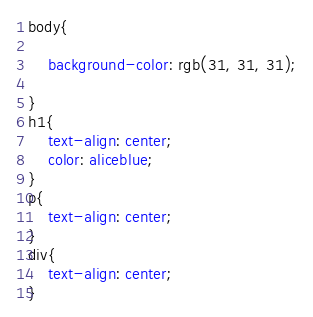Convert code to text. <code><loc_0><loc_0><loc_500><loc_500><_CSS_>body{

    background-color: rgb(31, 31, 31);
    
}
h1{
    text-align: center;
    color: aliceblue;
}
p{
    text-align: center;
}
div{
    text-align: center;
}</code> 